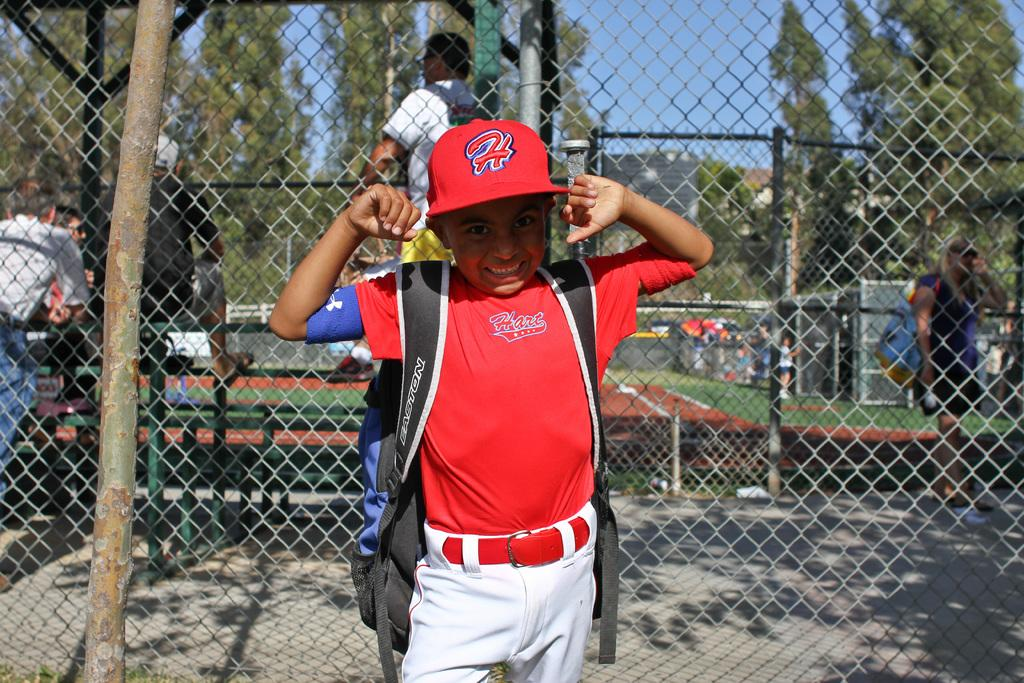Provide a one-sentence caption for the provided image. A young boy is wearing a red baseball jersey and a red hat with the letter H on it. 